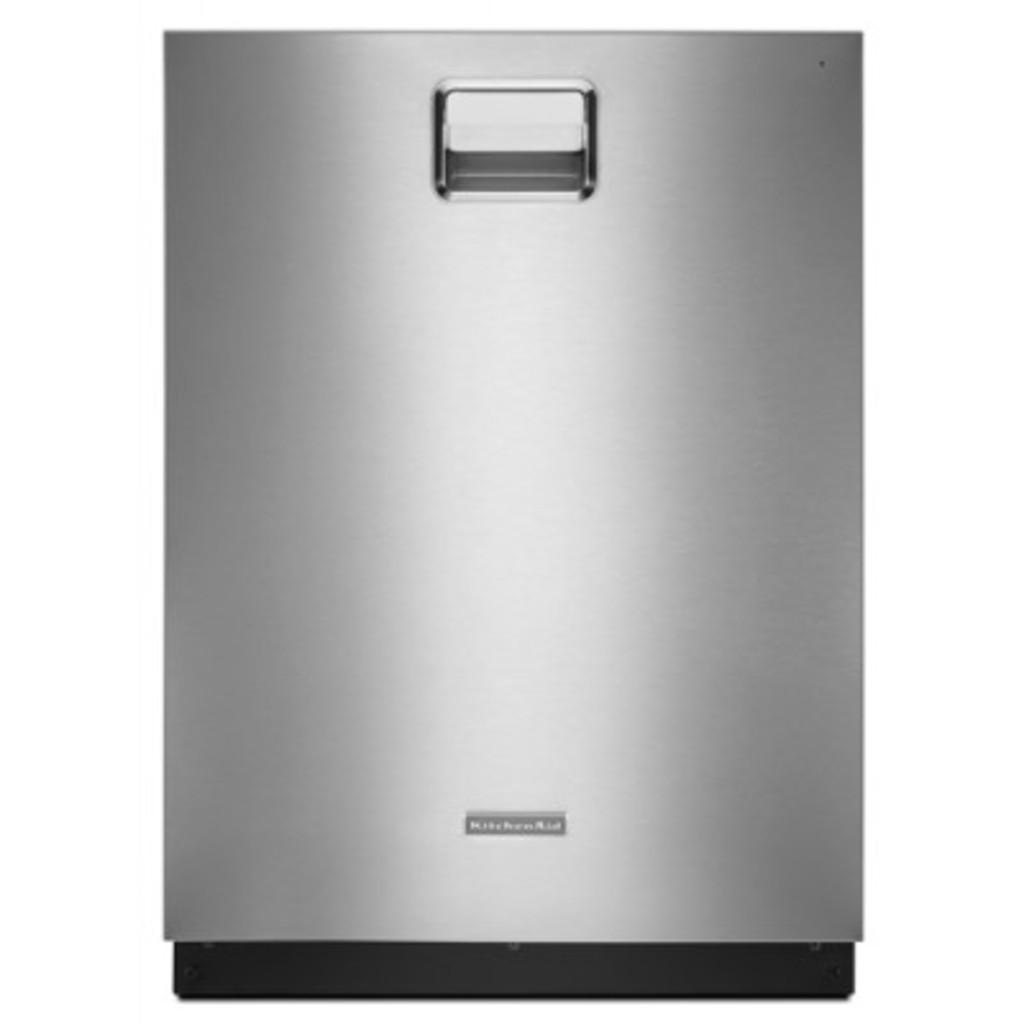What can be seen in the image? There is an object in the image. Can you describe the color of the object? The object is of ash color. What part of the object is responsible for transmitting nerve signals? There is no information about the object's function or composition in the image, so it is impossible to determine if it has any parts related to nerve signals. 